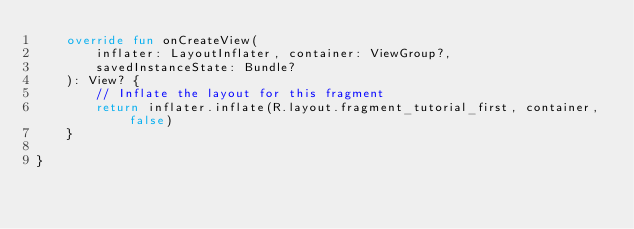Convert code to text. <code><loc_0><loc_0><loc_500><loc_500><_Kotlin_>    override fun onCreateView(
        inflater: LayoutInflater, container: ViewGroup?,
        savedInstanceState: Bundle?
    ): View? {
        // Inflate the layout for this fragment
        return inflater.inflate(R.layout.fragment_tutorial_first, container, false)
    }

}</code> 